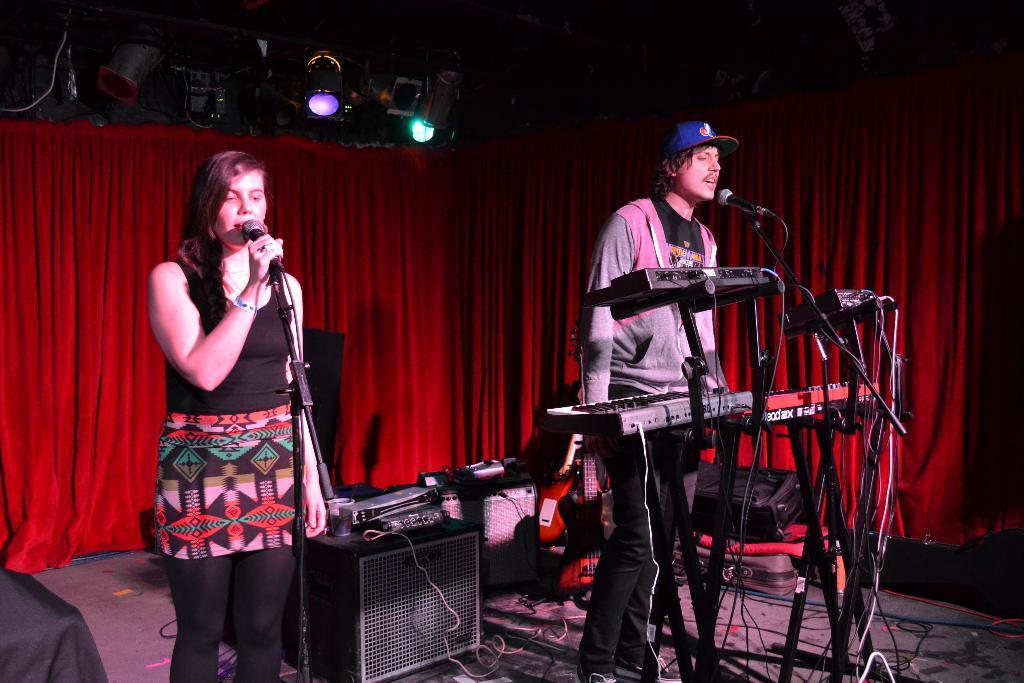Can you describe this image briefly? on a stage which is surrounded with red carpet and there is a man standing in front of piano and micro phone and singing a song. And on the other side there is a woman standing holding microphone and singing along with them. There is a sound box in between them. 